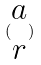<formula> <loc_0><loc_0><loc_500><loc_500>( \begin{matrix} a \\ r \end{matrix} )</formula> 